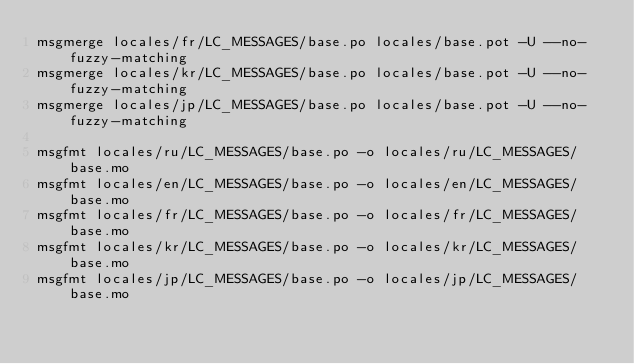<code> <loc_0><loc_0><loc_500><loc_500><_Bash_>msgmerge locales/fr/LC_MESSAGES/base.po locales/base.pot -U --no-fuzzy-matching
msgmerge locales/kr/LC_MESSAGES/base.po locales/base.pot -U --no-fuzzy-matching
msgmerge locales/jp/LC_MESSAGES/base.po locales/base.pot -U --no-fuzzy-matching

msgfmt locales/ru/LC_MESSAGES/base.po -o locales/ru/LC_MESSAGES/base.mo
msgfmt locales/en/LC_MESSAGES/base.po -o locales/en/LC_MESSAGES/base.mo
msgfmt locales/fr/LC_MESSAGES/base.po -o locales/fr/LC_MESSAGES/base.mo
msgfmt locales/kr/LC_MESSAGES/base.po -o locales/kr/LC_MESSAGES/base.mo
msgfmt locales/jp/LC_MESSAGES/base.po -o locales/jp/LC_MESSAGES/base.mo</code> 